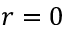<formula> <loc_0><loc_0><loc_500><loc_500>r = 0</formula> 